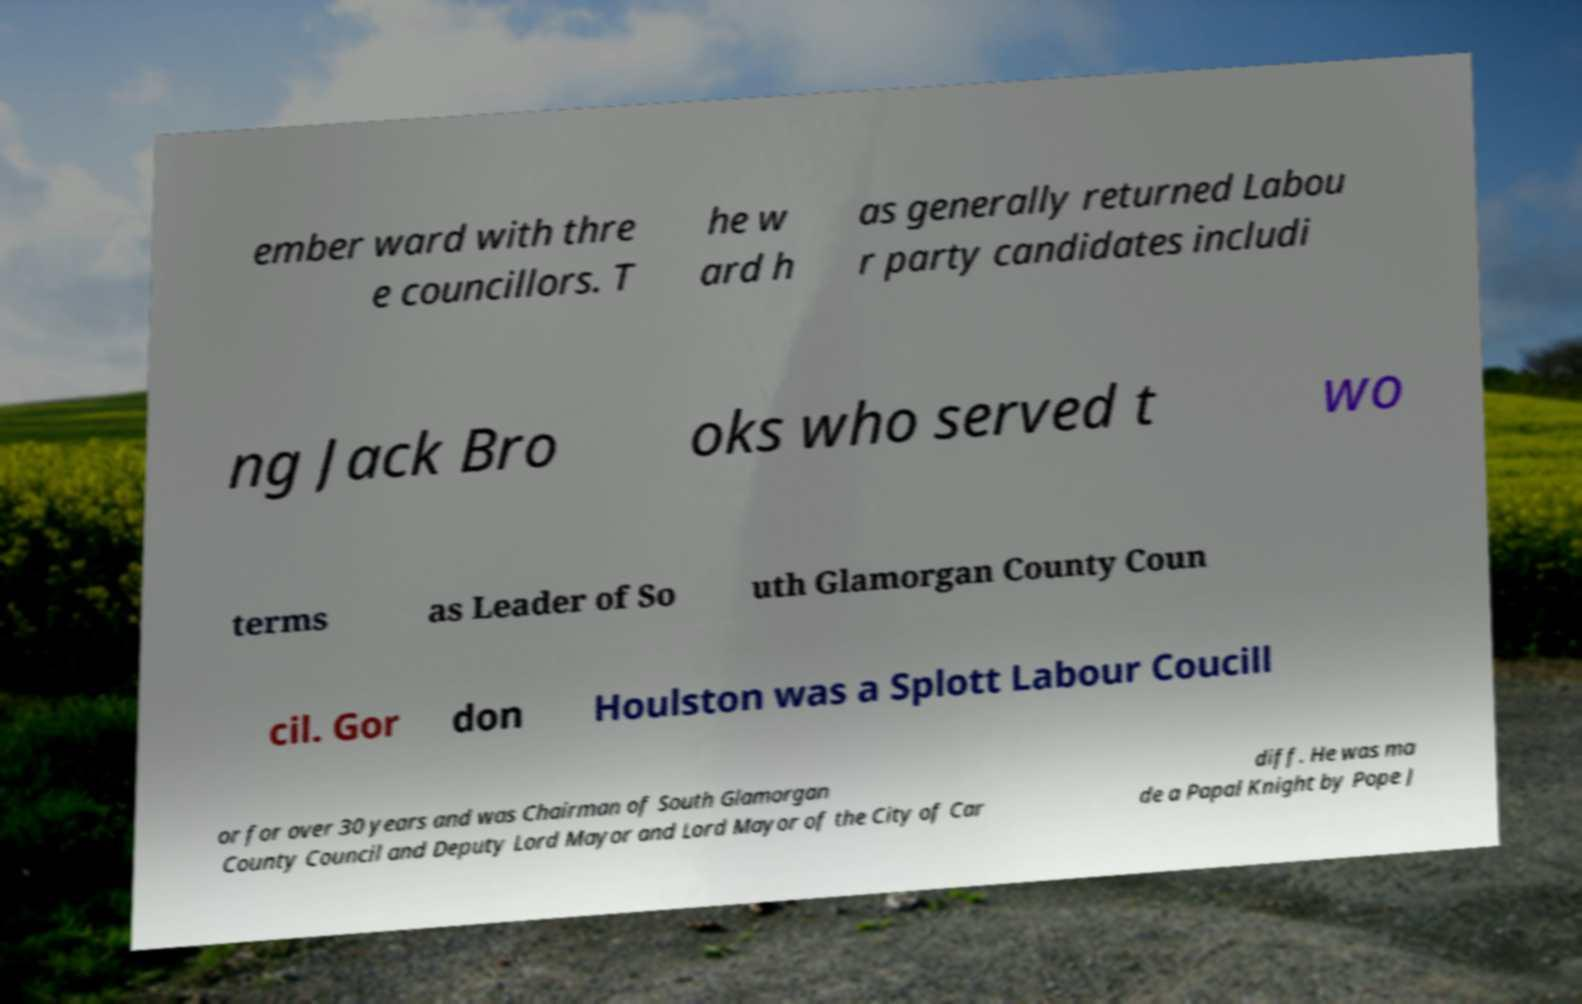I need the written content from this picture converted into text. Can you do that? ember ward with thre e councillors. T he w ard h as generally returned Labou r party candidates includi ng Jack Bro oks who served t wo terms as Leader of So uth Glamorgan County Coun cil. Gor don Houlston was a Splott Labour Coucill or for over 30 years and was Chairman of South Glamorgan County Council and Deputy Lord Mayor and Lord Mayor of the City of Car diff. He was ma de a Papal Knight by Pope J 